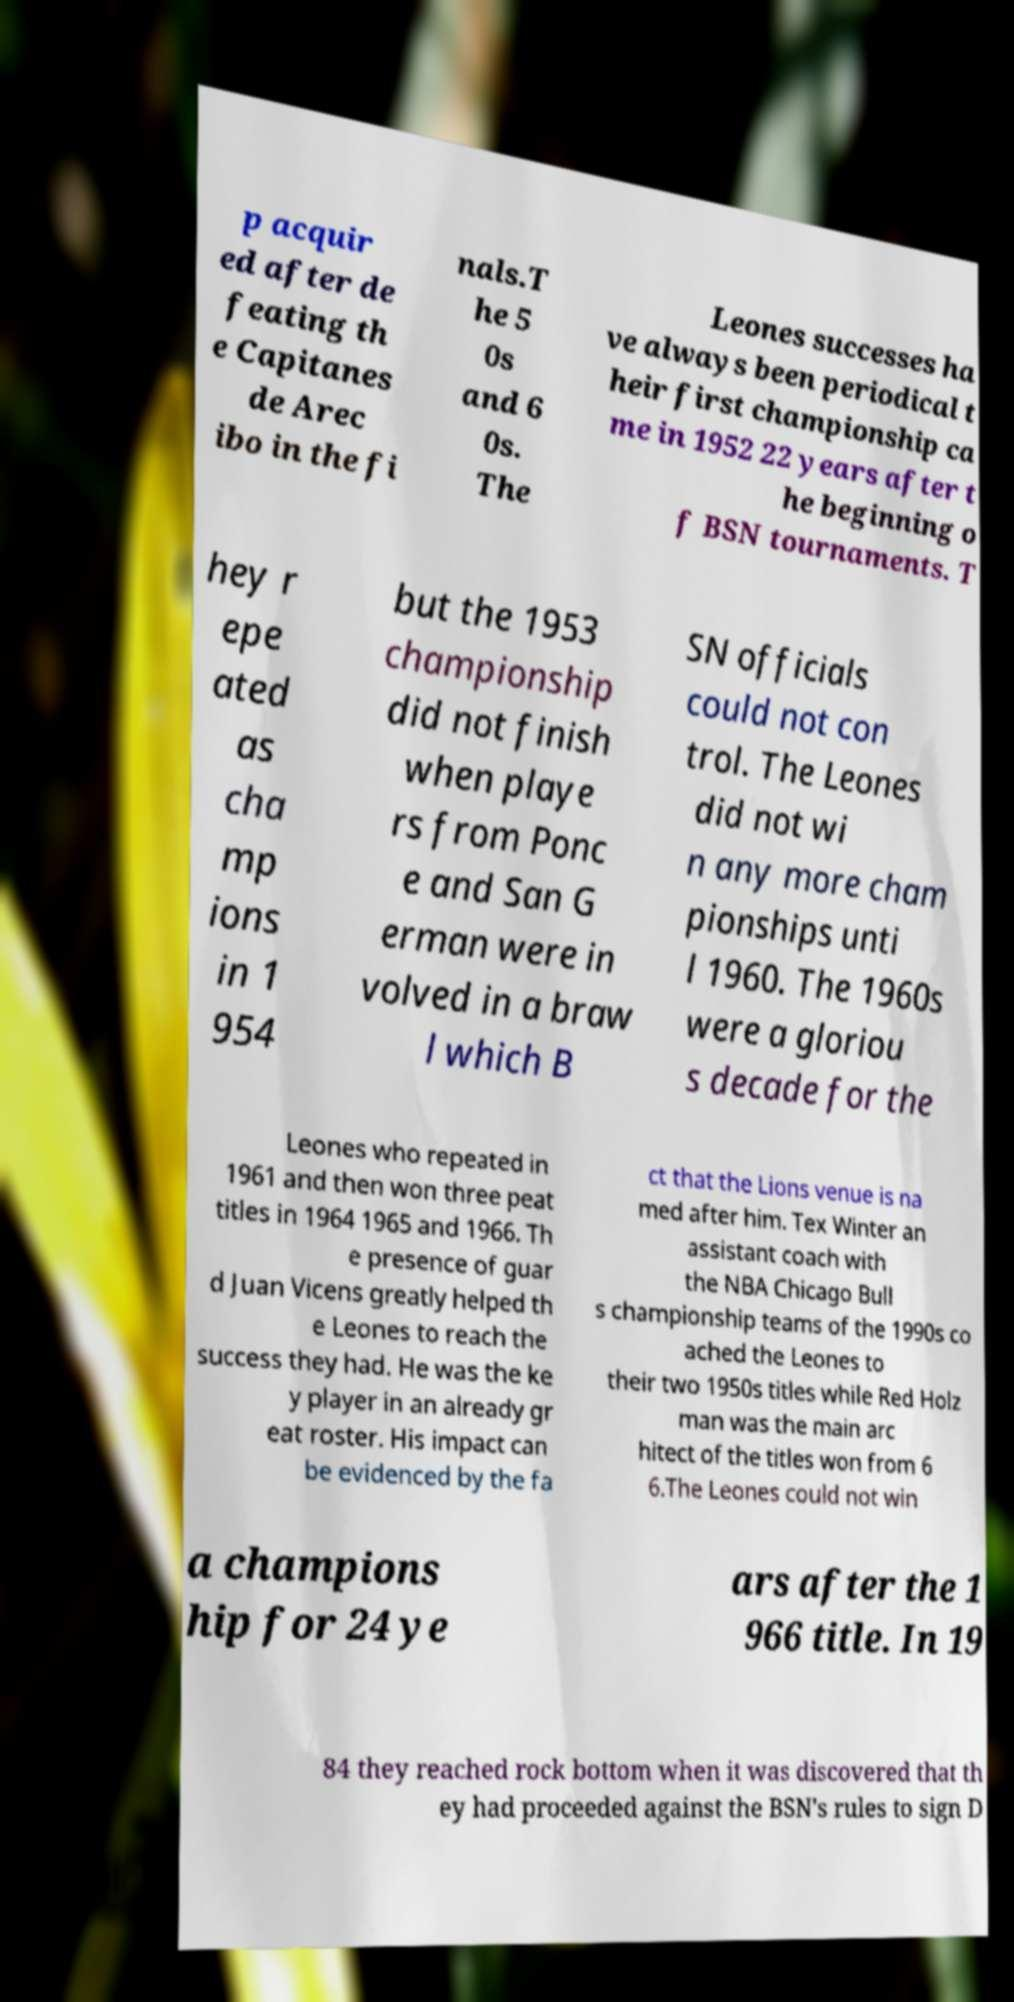Please read and relay the text visible in this image. What does it say? p acquir ed after de feating th e Capitanes de Arec ibo in the fi nals.T he 5 0s and 6 0s. The Leones successes ha ve always been periodical t heir first championship ca me in 1952 22 years after t he beginning o f BSN tournaments. T hey r epe ated as cha mp ions in 1 954 but the 1953 championship did not finish when playe rs from Ponc e and San G erman were in volved in a braw l which B SN officials could not con trol. The Leones did not wi n any more cham pionships unti l 1960. The 1960s were a gloriou s decade for the Leones who repeated in 1961 and then won three peat titles in 1964 1965 and 1966. Th e presence of guar d Juan Vicens greatly helped th e Leones to reach the success they had. He was the ke y player in an already gr eat roster. His impact can be evidenced by the fa ct that the Lions venue is na med after him. Tex Winter an assistant coach with the NBA Chicago Bull s championship teams of the 1990s co ached the Leones to their two 1950s titles while Red Holz man was the main arc hitect of the titles won from 6 6.The Leones could not win a champions hip for 24 ye ars after the 1 966 title. In 19 84 they reached rock bottom when it was discovered that th ey had proceeded against the BSN's rules to sign D 